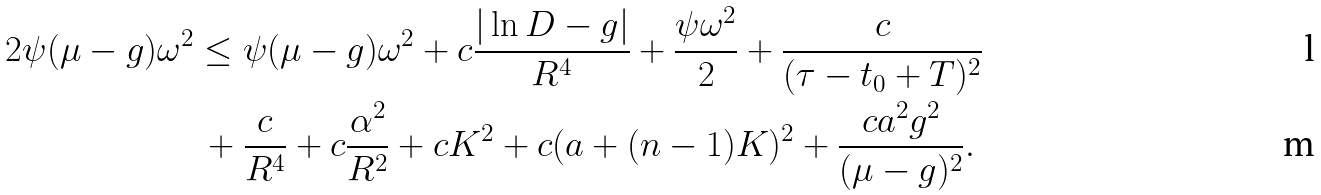Convert formula to latex. <formula><loc_0><loc_0><loc_500><loc_500>2 \psi ( \mu - g ) \omega ^ { 2 } & \leq \psi ( \mu - g ) \omega ^ { 2 } + c \frac { | \ln D - g | } { R ^ { 4 } } + \frac { \psi \omega ^ { 2 } } { 2 } + \frac { c } { ( \tau - t _ { 0 } + T ) ^ { 2 } } \\ & \, + \frac { c } { R ^ { 4 } } + c \frac { \alpha ^ { 2 } } { R ^ { 2 } } + c K ^ { 2 } + c ( a + ( n - 1 ) K ) ^ { 2 } + \frac { c a ^ { 2 } g ^ { 2 } } { ( \mu - g ) ^ { 2 } } .</formula> 